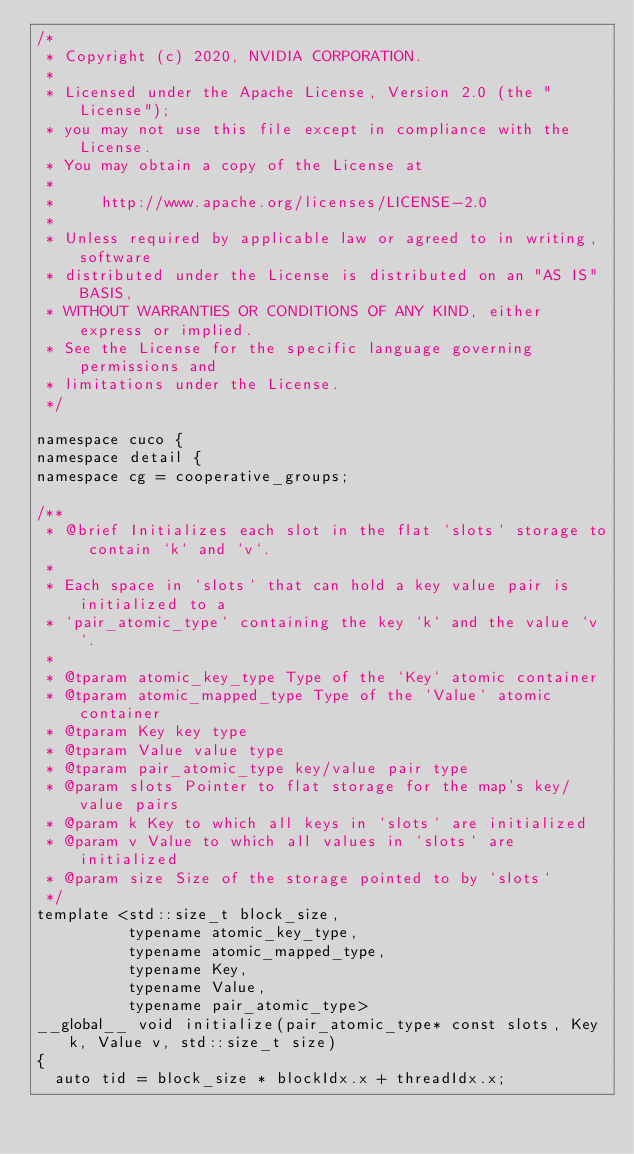Convert code to text. <code><loc_0><loc_0><loc_500><loc_500><_Cuda_>/*
 * Copyright (c) 2020, NVIDIA CORPORATION.
 *
 * Licensed under the Apache License, Version 2.0 (the "License");
 * you may not use this file except in compliance with the License.
 * You may obtain a copy of the License at
 *
 *     http://www.apache.org/licenses/LICENSE-2.0
 *
 * Unless required by applicable law or agreed to in writing, software
 * distributed under the License is distributed on an "AS IS" BASIS,
 * WITHOUT WARRANTIES OR CONDITIONS OF ANY KIND, either express or implied.
 * See the License for the specific language governing permissions and
 * limitations under the License.
 */

namespace cuco {
namespace detail {
namespace cg = cooperative_groups;

/**
 * @brief Initializes each slot in the flat `slots` storage to contain `k` and `v`.
 *
 * Each space in `slots` that can hold a key value pair is initialized to a
 * `pair_atomic_type` containing the key `k` and the value `v`.
 *
 * @tparam atomic_key_type Type of the `Key` atomic container
 * @tparam atomic_mapped_type Type of the `Value` atomic container
 * @tparam Key key type
 * @tparam Value value type
 * @tparam pair_atomic_type key/value pair type
 * @param slots Pointer to flat storage for the map's key/value pairs
 * @param k Key to which all keys in `slots` are initialized
 * @param v Value to which all values in `slots` are initialized
 * @param size Size of the storage pointed to by `slots`
 */
template <std::size_t block_size,
          typename atomic_key_type,
          typename atomic_mapped_type,
          typename Key,
          typename Value,
          typename pair_atomic_type>
__global__ void initialize(pair_atomic_type* const slots, Key k, Value v, std::size_t size)
{
  auto tid = block_size * blockIdx.x + threadIdx.x;</code> 